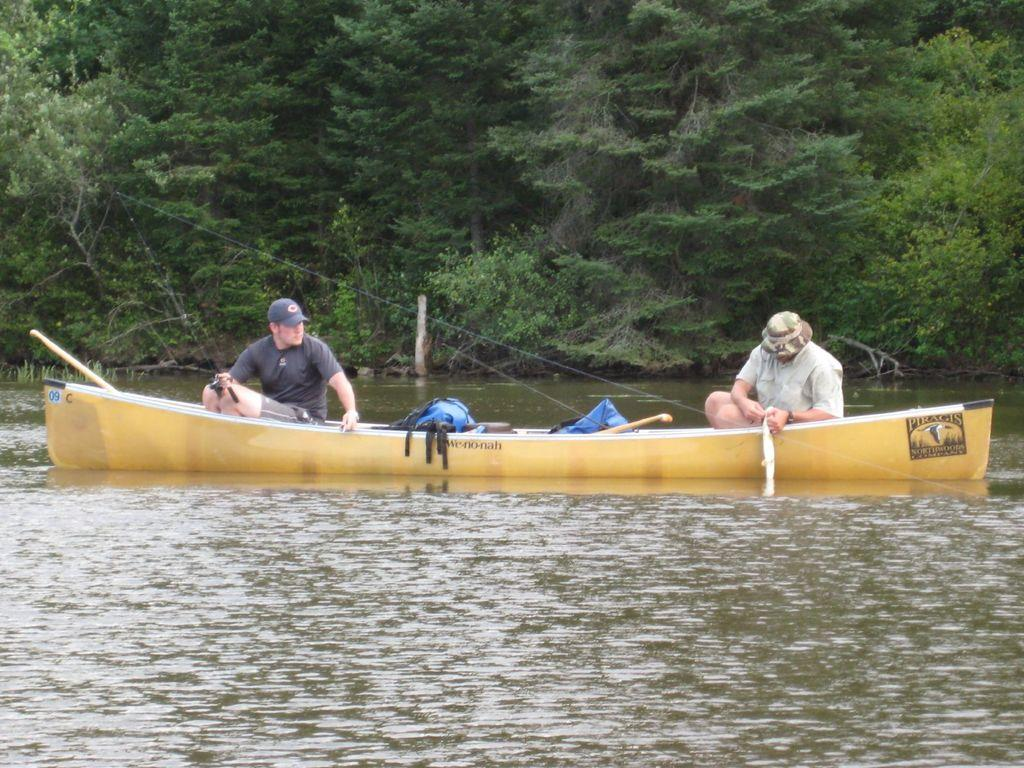What is the main subject of the image? The main subject of the image is water. What is located in the water? There is a boat in the water. Who is in the boat? There are two persons sitting in the boat. What are the persons wearing? The persons are wearing caps. What else is in the boat? There is a bag in the boat. What can be seen in the background of the image? There are trees visible in the image. What type of cloud can be seen in the image? There is no cloud present in the image; it only features water, a boat, two persons, caps, a bag, and trees. What is the ongoing war in the image? There is no war depicted in the image; it is a peaceful scene with a boat on water. 